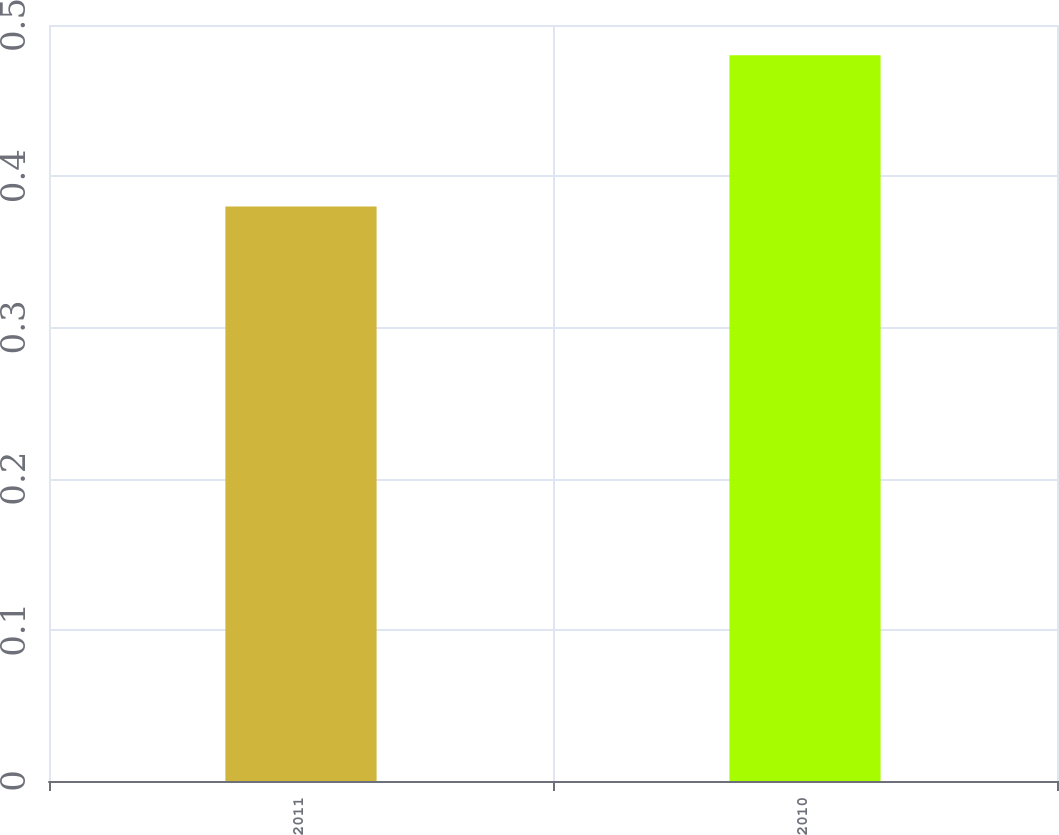Convert chart to OTSL. <chart><loc_0><loc_0><loc_500><loc_500><bar_chart><fcel>2011<fcel>2010<nl><fcel>0.38<fcel>0.48<nl></chart> 